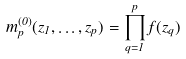Convert formula to latex. <formula><loc_0><loc_0><loc_500><loc_500>m _ { p } ^ { ( 0 ) } ( z _ { 1 } , \dots , z _ { p } ) = \prod _ { q = 1 } ^ { p } f ( z _ { q } )</formula> 